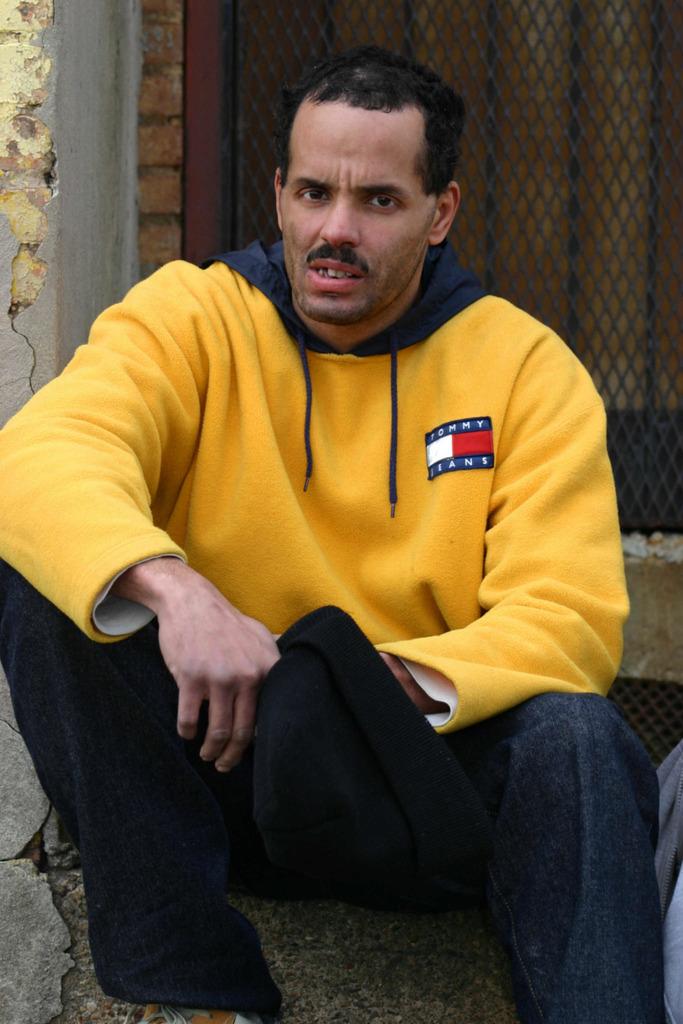What brand is the man's hoodie?
Provide a short and direct response. Tommy jeans. He wear levis brand?
Provide a succinct answer. No. 